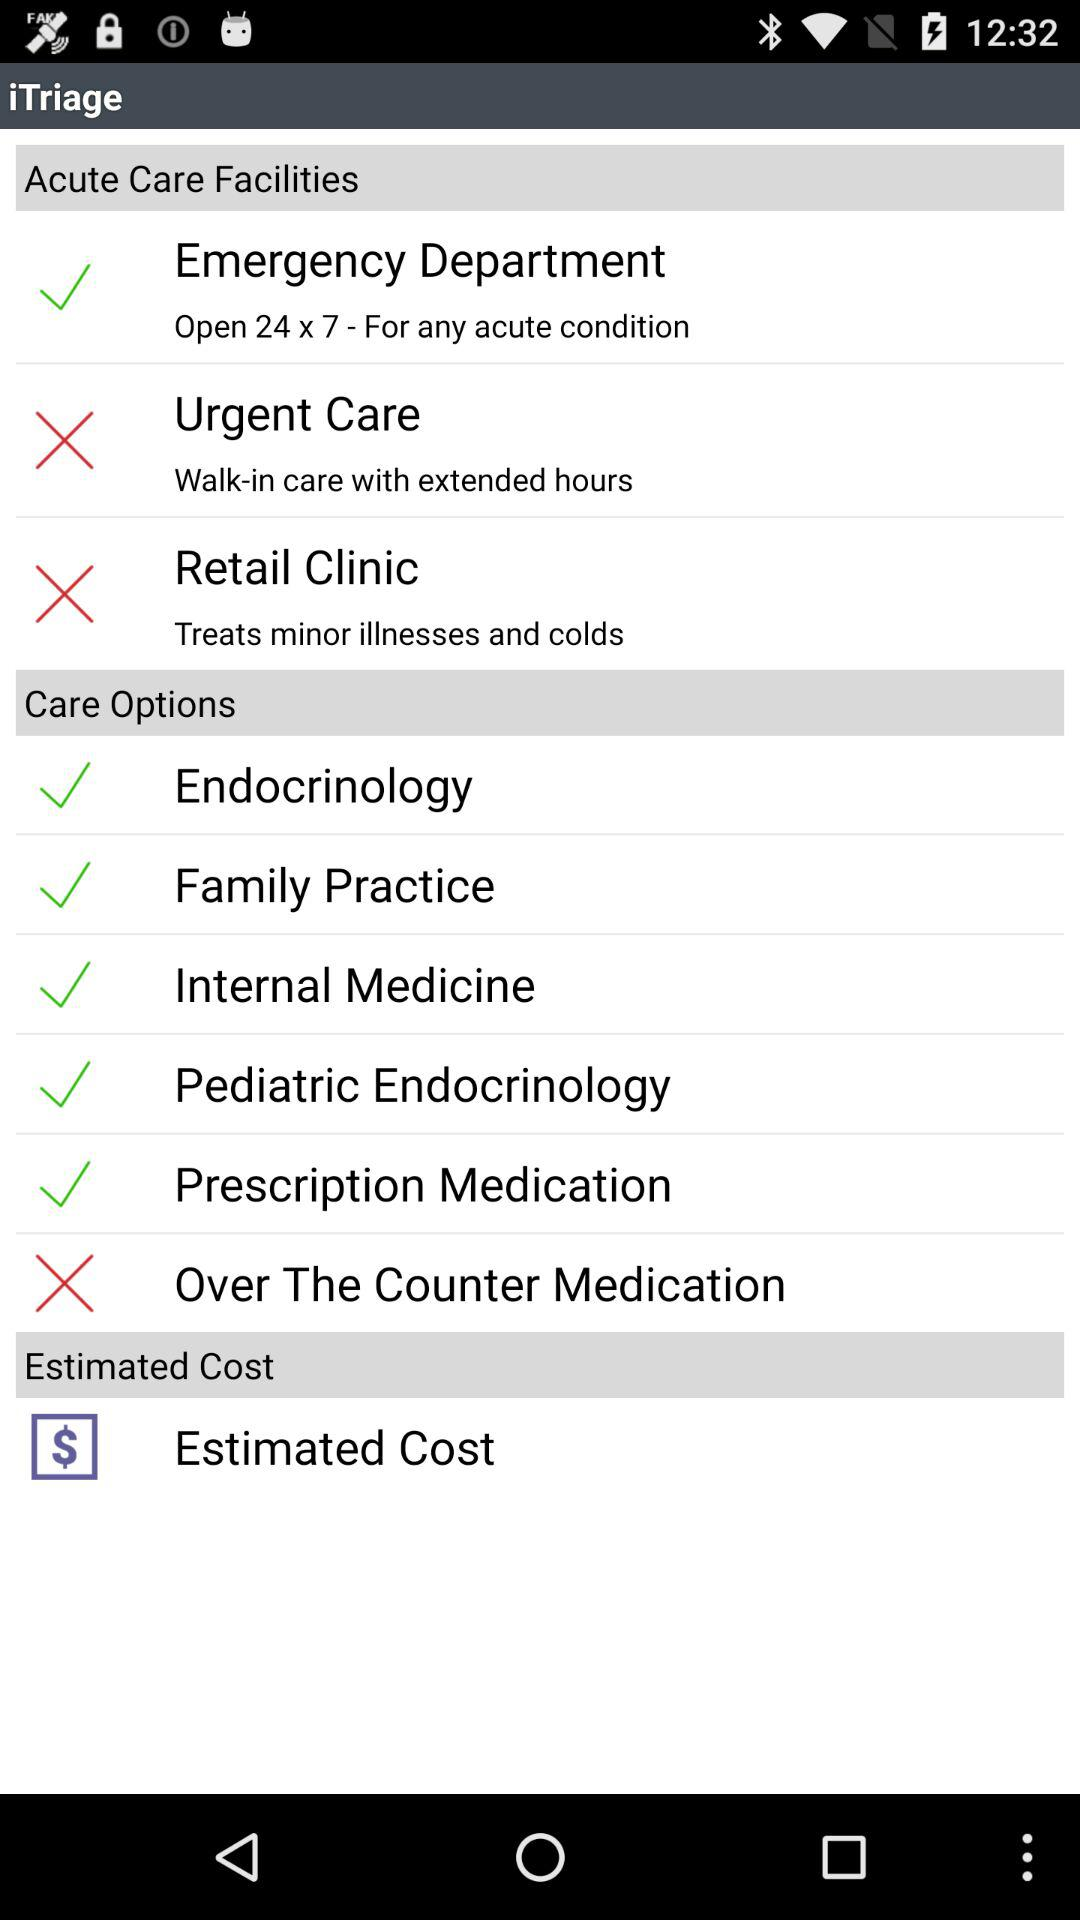What option is selected in "Acute Care Facilities"? The selected option is "Emergency Department". 